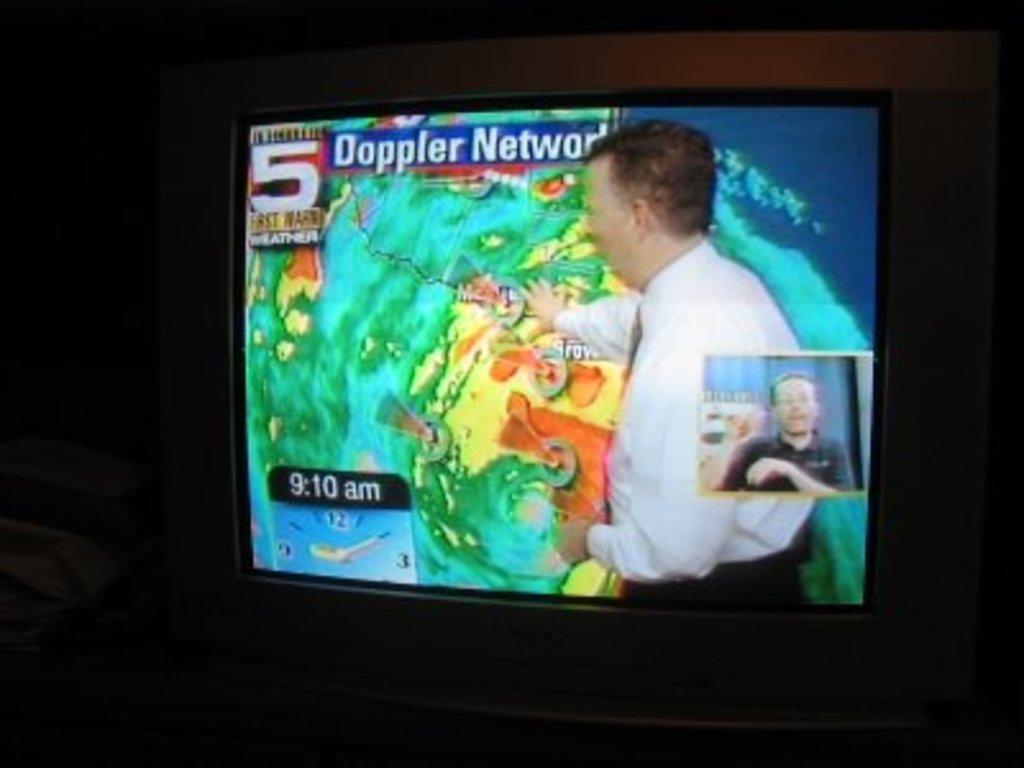What is the main object in the image? There is a television screen in the image. What can be seen on the television screen? Two people are visible on the television screen. What are the people wearing? The people are wearing clothes. What else is visible on the television screen? There is text visible on the television screen. What type of plastic jar can be seen on the television screen? There is no plastic jar present on the television screen; the image only shows a television screen with two people and text. 